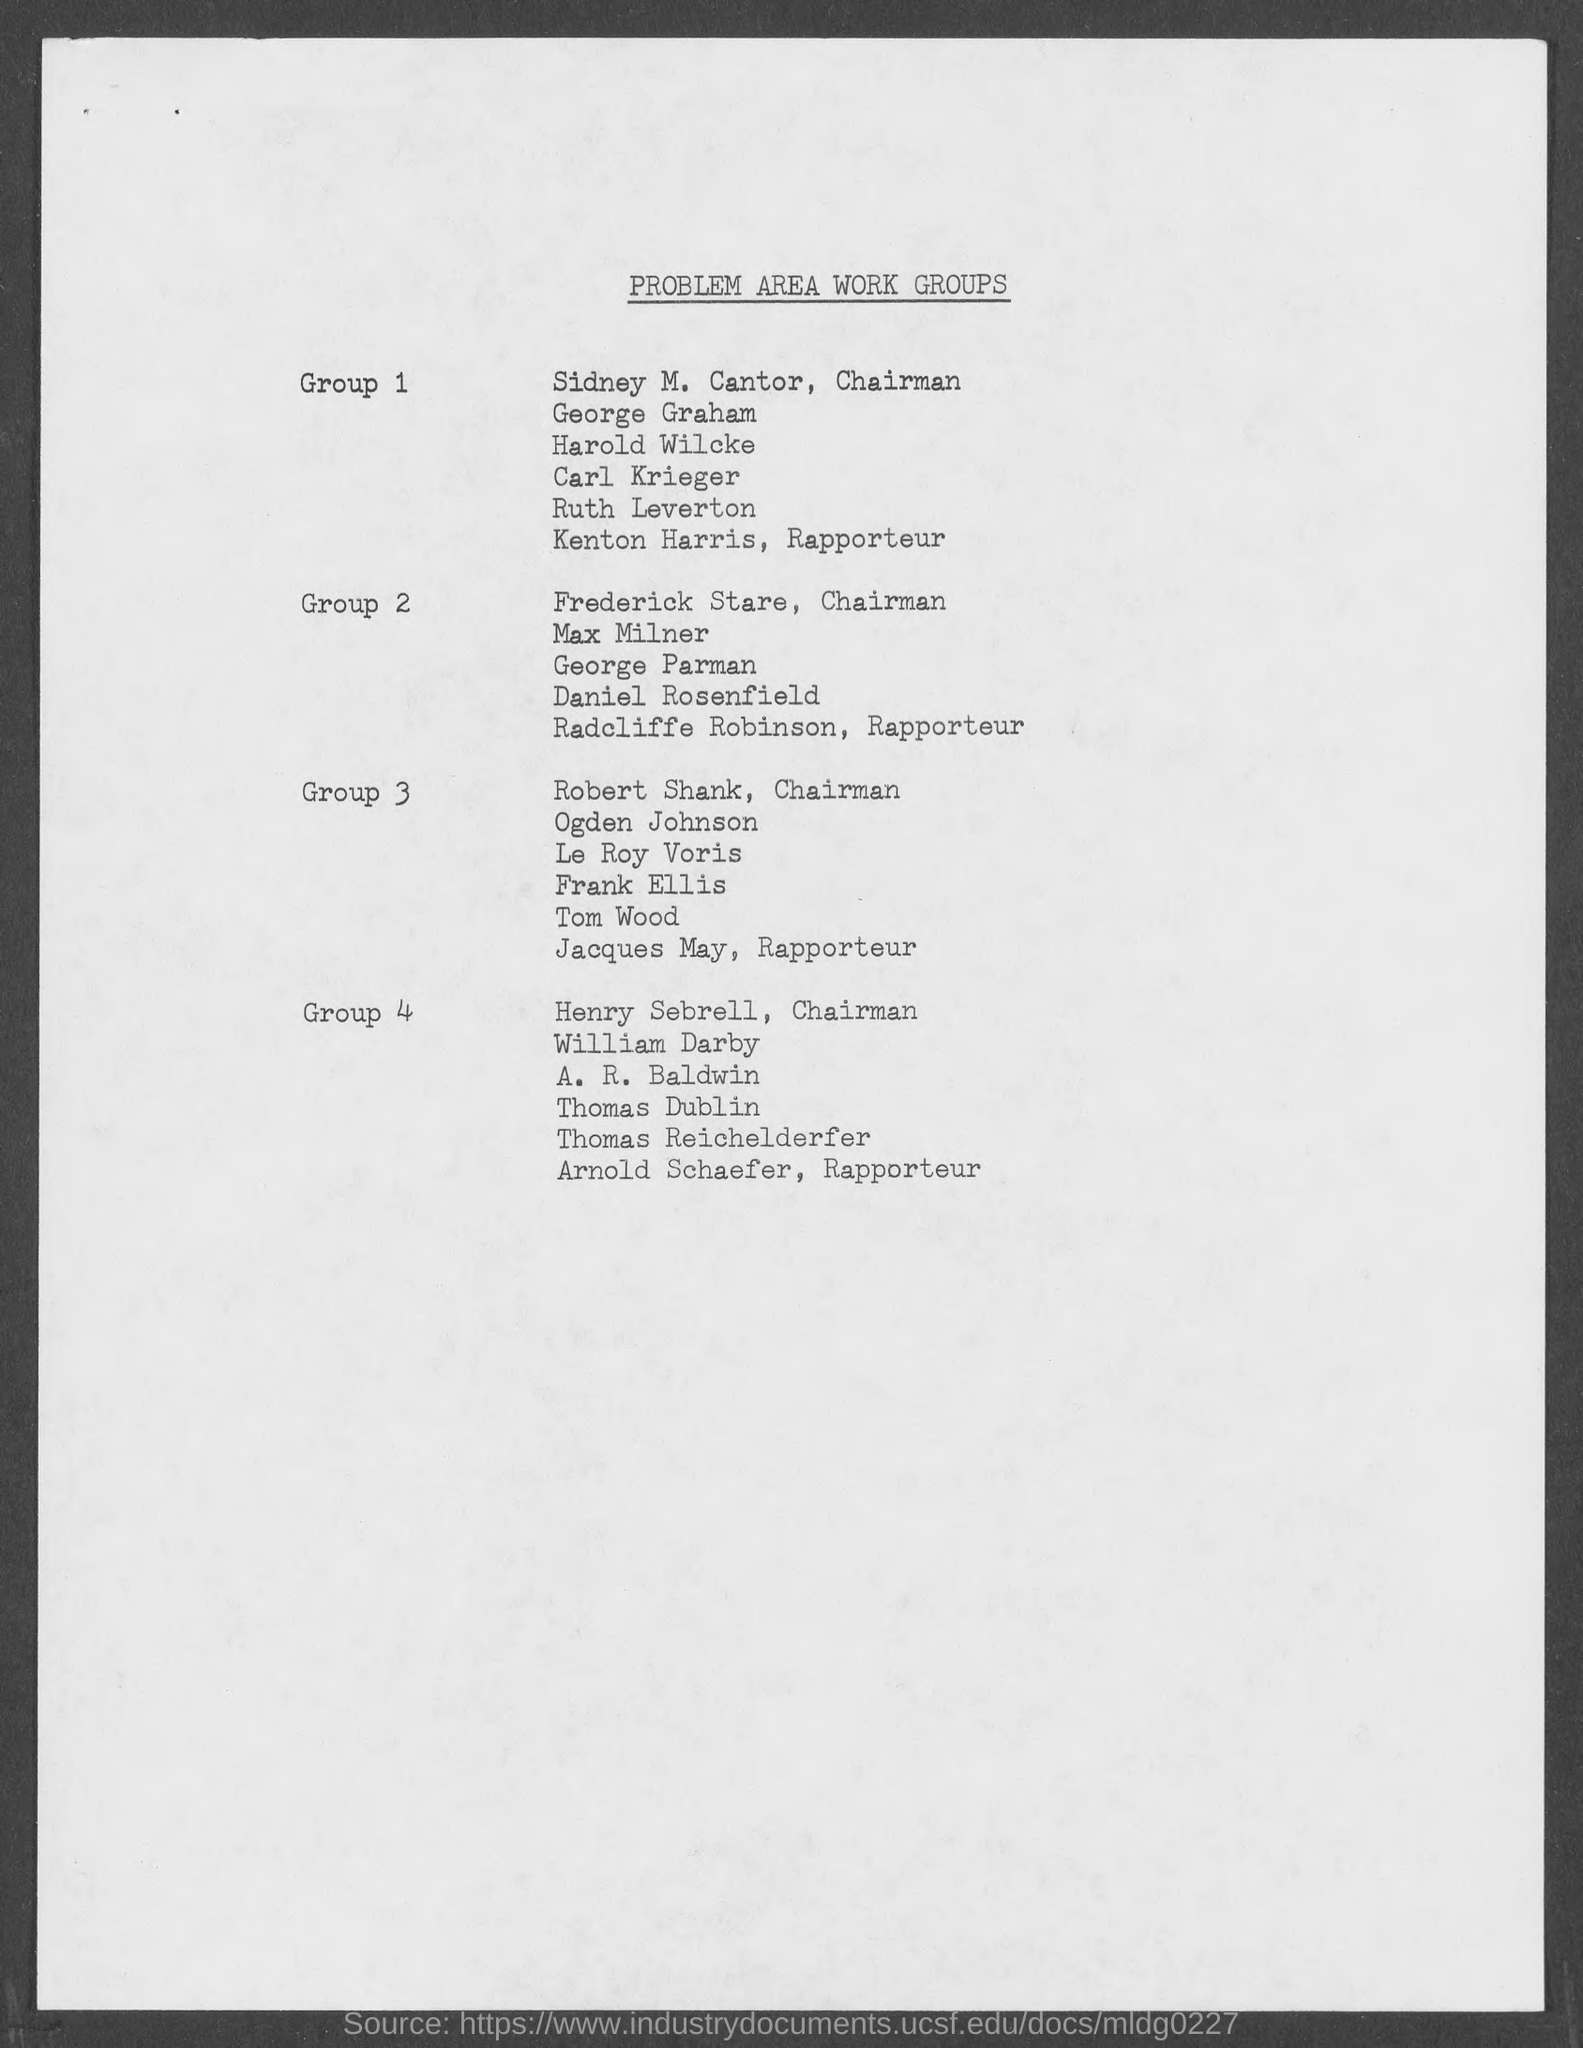Give some essential details in this illustration. Sidney M. Cantor is the chairman of Group 1. The heading of the document on top is titled "Problem Area Work Groups. Henry Sebrell is the chairman of Group 4. Radcliffe Robinson is the rapporteur of Group 2. The rapporteur of Group 1 is Kenton Harris. 